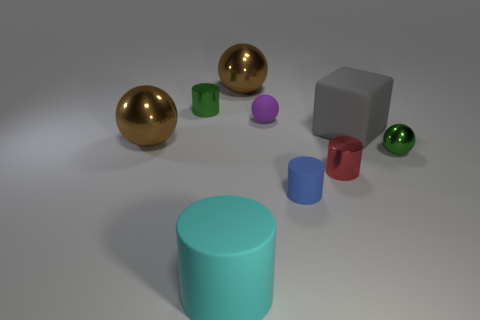Subtract all metal balls. How many balls are left? 1 Subtract all brown spheres. How many spheres are left? 2 Subtract all purple things. Subtract all tiny blue matte cylinders. How many objects are left? 7 Add 8 cyan matte cylinders. How many cyan matte cylinders are left? 9 Add 5 small green blocks. How many small green blocks exist? 5 Subtract 1 cyan cylinders. How many objects are left? 8 Subtract all blocks. How many objects are left? 8 Subtract 1 cylinders. How many cylinders are left? 3 Subtract all blue cylinders. Subtract all red balls. How many cylinders are left? 3 Subtract all brown blocks. How many gray balls are left? 0 